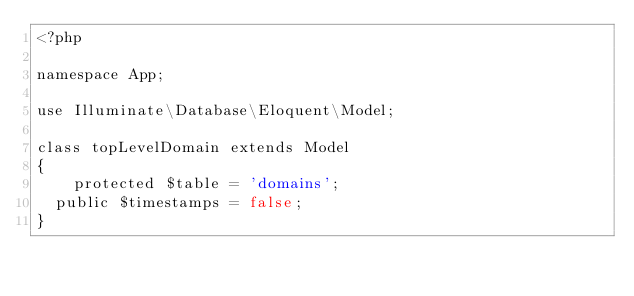Convert code to text. <code><loc_0><loc_0><loc_500><loc_500><_PHP_><?php

namespace App;

use Illuminate\Database\Eloquent\Model;

class topLevelDomain extends Model
{
    protected $table = 'domains';
	public $timestamps = false;
}
</code> 